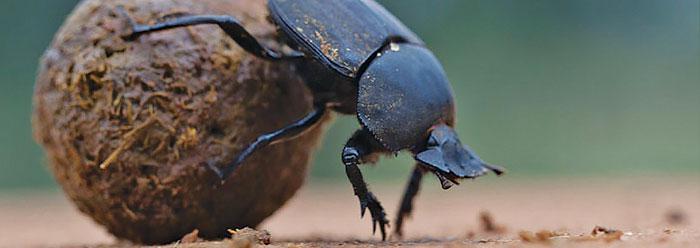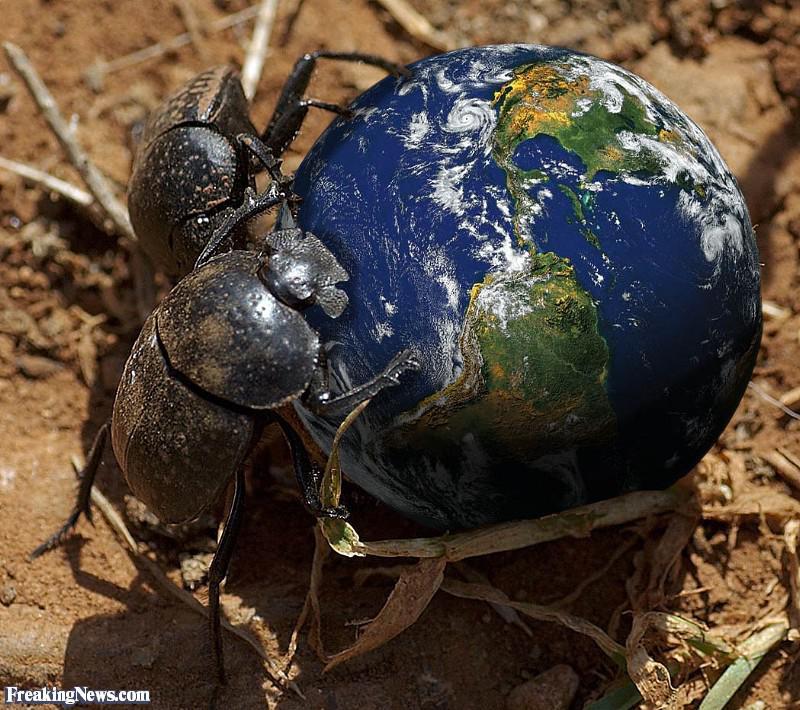The first image is the image on the left, the second image is the image on the right. For the images displayed, is the sentence "In one of the images, more than one beetle is seen, interacting with the 'ball'." factually correct? Answer yes or no. Yes. The first image is the image on the left, the second image is the image on the right. Considering the images on both sides, is "There are no more than two dung beetles." valid? Answer yes or no. No. 